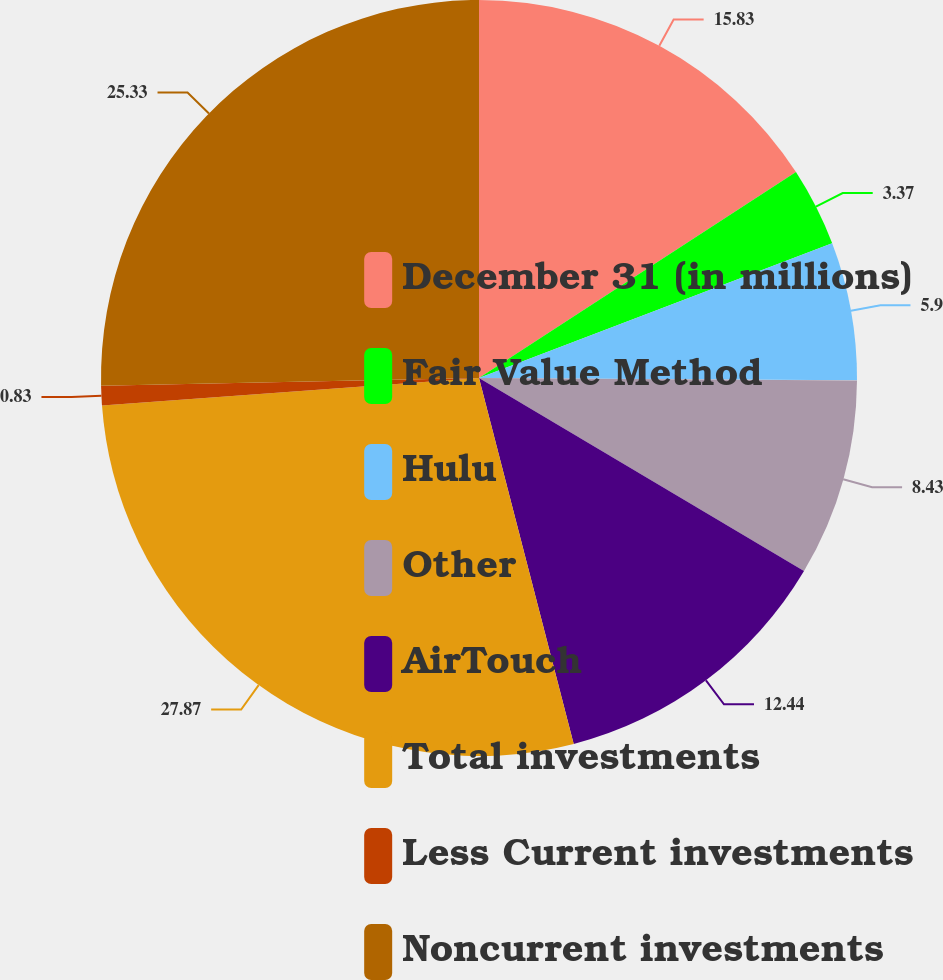Convert chart. <chart><loc_0><loc_0><loc_500><loc_500><pie_chart><fcel>December 31 (in millions)<fcel>Fair Value Method<fcel>Hulu<fcel>Other<fcel>AirTouch<fcel>Total investments<fcel>Less Current investments<fcel>Noncurrent investments<nl><fcel>15.83%<fcel>3.37%<fcel>5.9%<fcel>8.43%<fcel>12.44%<fcel>27.87%<fcel>0.83%<fcel>25.33%<nl></chart> 